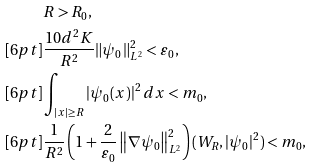<formula> <loc_0><loc_0><loc_500><loc_500>& R > R _ { 0 } , \\ [ 6 p t ] & \frac { 1 0 d ^ { 2 } K } { R ^ { 2 } } \| \psi _ { 0 } \| _ { L ^ { 2 } } ^ { 2 } < \varepsilon _ { 0 } , \\ [ 6 p t ] & \int _ { | x | \geq R } | \psi _ { 0 } ( x ) | ^ { 2 } \, d x < m _ { 0 } , \\ [ 6 p t ] & \frac { 1 } { R ^ { 2 } } \left ( 1 + \frac { 2 } { \varepsilon _ { 0 } } \left \| \nabla \psi _ { 0 } \right \| _ { L ^ { 2 } } ^ { 2 } \right ) ( W _ { R } , | \psi _ { 0 } | ^ { 2 } ) < m _ { 0 } ,</formula> 